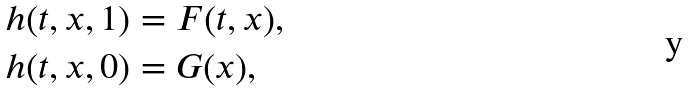Convert formula to latex. <formula><loc_0><loc_0><loc_500><loc_500>h ( t , x , 1 ) & = F ( t , x ) , \\ h ( t , x , 0 ) & = G ( x ) ,</formula> 